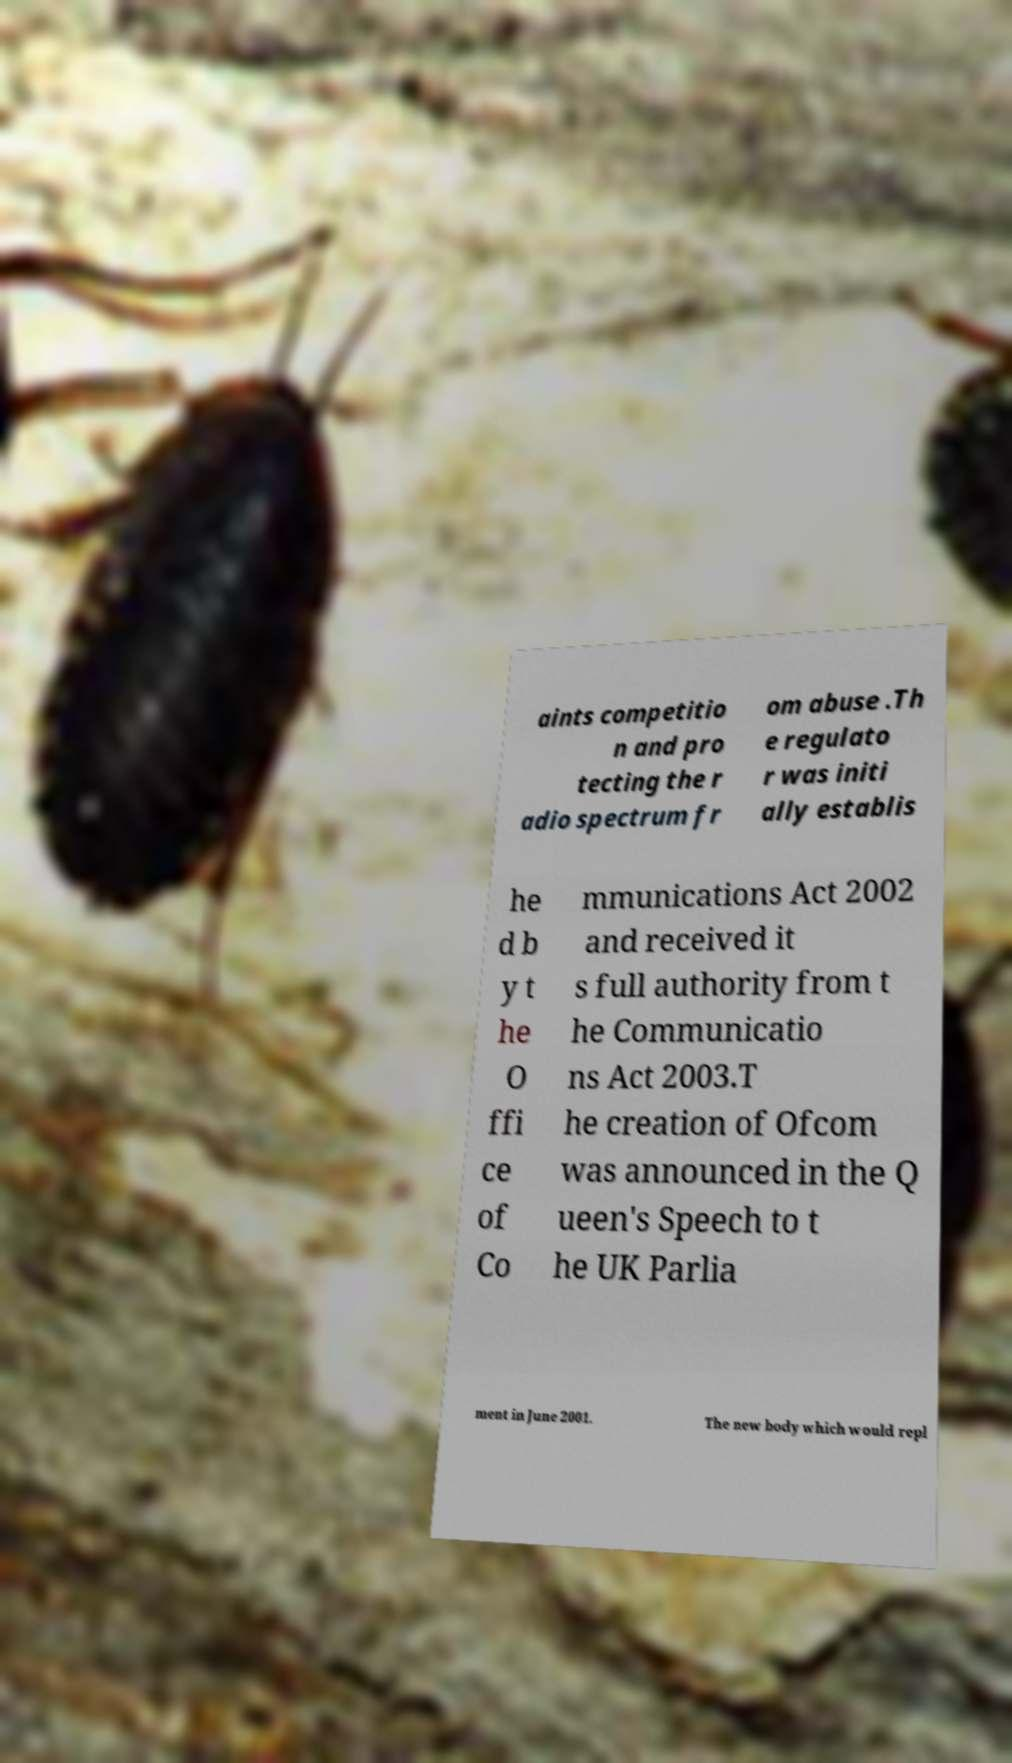For documentation purposes, I need the text within this image transcribed. Could you provide that? aints competitio n and pro tecting the r adio spectrum fr om abuse .Th e regulato r was initi ally establis he d b y t he O ffi ce of Co mmunications Act 2002 and received it s full authority from t he Communicatio ns Act 2003.T he creation of Ofcom was announced in the Q ueen's Speech to t he UK Parlia ment in June 2001. The new body which would repl 